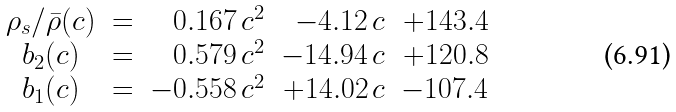Convert formula to latex. <formula><loc_0><loc_0><loc_500><loc_500>\begin{array} { c c r r r } \rho _ { s } / \bar { \rho } ( c ) & = & \, 0 . 1 6 7 \, c ^ { 2 } & - 4 . 1 2 \, c & + 1 4 3 . 4 \\ b _ { 2 } ( c ) & = & \, 0 . 5 7 9 \, c ^ { 2 } & - 1 4 . 9 4 \, c & + 1 2 0 . 8 \\ b _ { 1 } ( c ) & = & - 0 . 5 5 8 \, c ^ { 2 } & + 1 4 . 0 2 \, c & - 1 0 7 . 4 \end{array}</formula> 